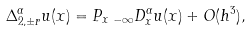Convert formula to latex. <formula><loc_0><loc_0><loc_500><loc_500>\Delta _ { 2 , \pm r } ^ { \alpha } u ( x ) = P _ { x } \, _ { - \infty } D _ { x } ^ { \alpha } u ( x ) + O ( h ^ { 3 } ) ,</formula> 